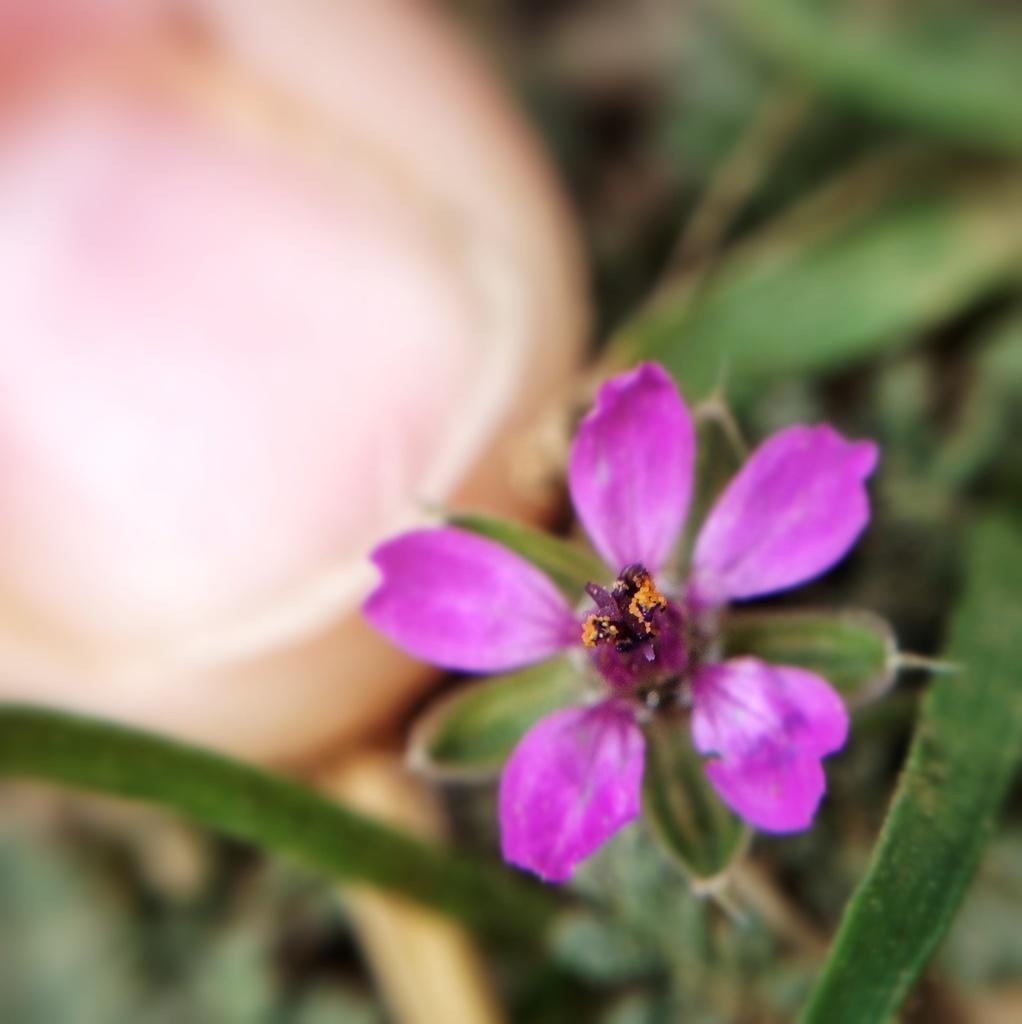What type of living organisms can be seen in the image? Plants can be seen in the image. Can you describe any specific features of the plants? There is a purple color flower in the image. What part of a person is visible in the image? A person's finger is visible in the image. What type of oil can be seen dripping from the flower in the image? There is no oil present in the image, and the flower is not depicted as dripping anything. 